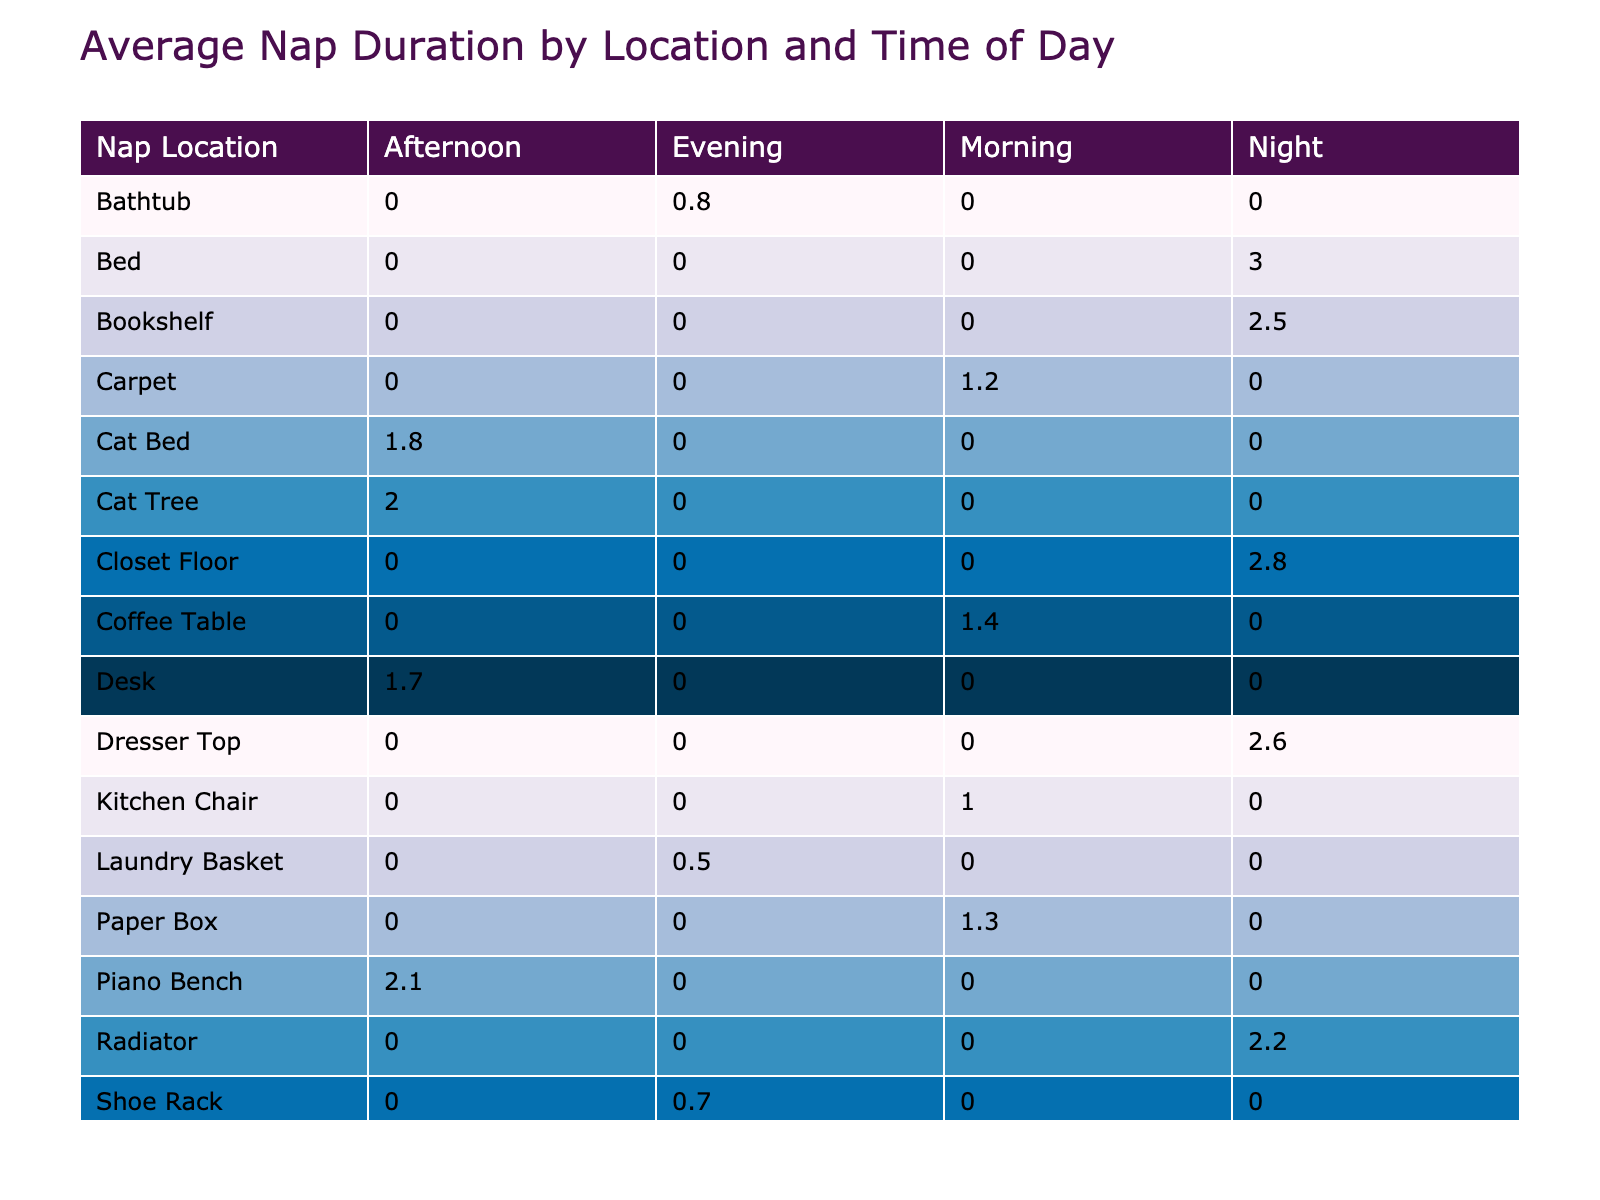What is the average nap duration for cats on the windowsill in the morning? The table shows that the nap duration for cats on the windowsill in the morning is 1.5 hours. Since there is only one entry for this category, the average is simply the value itself.
Answer: 1.5 hours Which nap location has the highest average nap duration in the afternoon? In the afternoon, the nap durations are 2 hours for the cat tree, 1.8 hours for the cat bed, 1.7 hours for the desk, and 2.1 hours for the piano bench. The highest average is 2.1 hours for the piano bench.
Answer: Piano bench (2.1 hours) Is there a location where cats take shorter naps on average than 1 hour in the evening? Reviewing the evening data, the nap durations are 1 hour for the sofa, 0.8 hours for the bathtub, and 0.7 hours for the shoe rack. The shoe rack has the shortest average at 0.7 hours, which is less than 1 hour.
Answer: Yes What is the total average nap duration for all nap locations during the night? The average nap durations during the night are 3 hours for the bed, 2.5 hours for the bookshelf, 2.2 hours for the radiator, 2.8 hours for the closet floor, and 2.6 hours for the dresser top. Summing these up gives 3 + 2.5 + 2.2 + 2.8 + 2.6 = 13.1 hours. Then, divide by the number of entries (5), which results in an average of 2.62 hours for the night naps.
Answer: 2.62 hours How many nap locations have an average duration of 2 hours or more? Based on the average nap durations in the table, the following nap locations have durations of 2 hours or more: cat tree (2), piano bench (2.1), bookshelf (2.5), closet floor (2.8), and dresser top (2.6). That totals to five locations.
Answer: 5 locations 